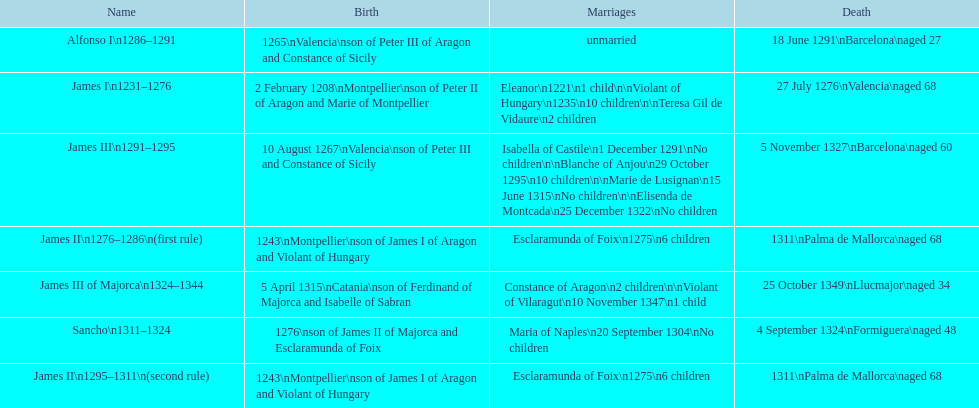Was james iii or sancho born in the year 1276? Sancho. 